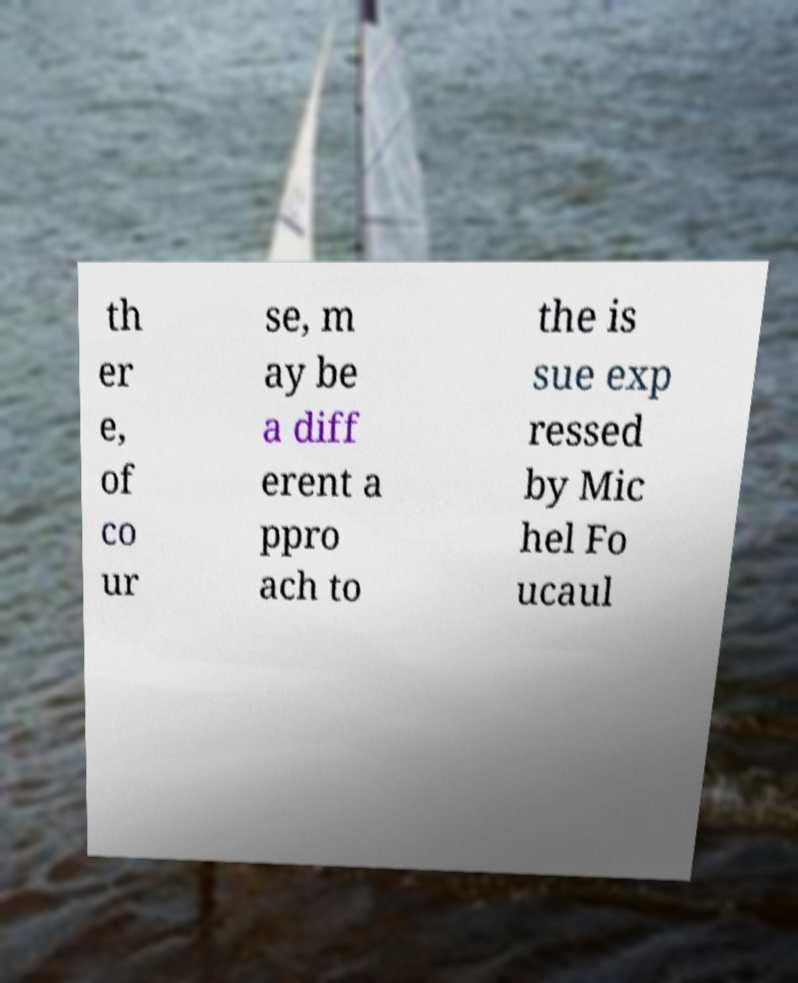Could you extract and type out the text from this image? th er e, of co ur se, m ay be a diff erent a ppro ach to the is sue exp ressed by Mic hel Fo ucaul 